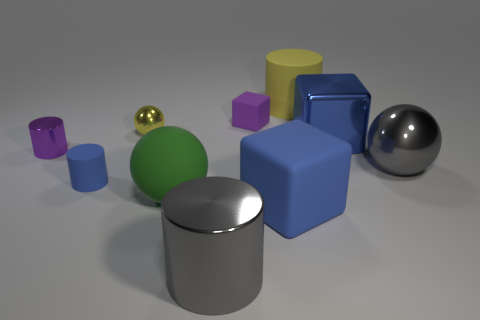There is a metal cylinder left of the big shiny cylinder; what size is it?
Offer a terse response. Small. What number of objects are either large things on the left side of the large blue matte block or yellow objects that are to the left of the big green rubber ball?
Offer a terse response. 3. Is there any other thing that is the same color as the rubber ball?
Keep it short and to the point. No. Is the number of large blue metallic blocks that are to the left of the small metal cylinder the same as the number of big gray metal spheres to the left of the tiny purple matte object?
Your response must be concise. Yes. Is the number of small blue objects that are behind the large green object greater than the number of tiny matte blocks?
Your response must be concise. No. How many things are large metallic objects that are left of the blue shiny cube or big blue metallic things?
Provide a short and direct response. 2. How many tiny purple cylinders are the same material as the large gray cylinder?
Provide a short and direct response. 1. What shape is the big metal thing that is the same color as the small matte cylinder?
Your response must be concise. Cube. Are there any metal things that have the same shape as the yellow rubber thing?
Provide a short and direct response. Yes. What is the shape of the blue metallic object that is the same size as the yellow matte cylinder?
Provide a short and direct response. Cube. 